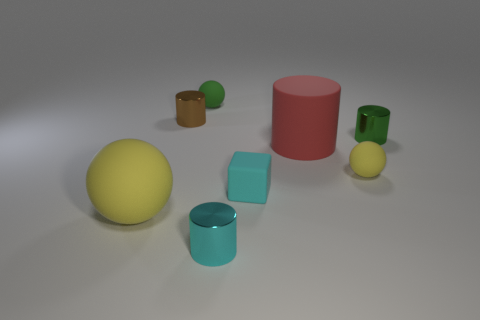The object that is the same color as the block is what shape?
Your response must be concise. Cylinder. What material is the tiny ball behind the tiny metal thing on the right side of the tiny matte sphere in front of the small green metal cylinder made of?
Make the answer very short. Rubber. There is a green object that is to the left of the tiny block; is it the same size as the cylinder that is behind the green metallic object?
Your answer should be very brief. Yes. What number of other things are the same material as the small brown thing?
Make the answer very short. 2. How many metal objects are tiny blocks or big gray spheres?
Your response must be concise. 0. Is the number of tiny yellow balls less than the number of large gray objects?
Your answer should be compact. No. Does the red matte cylinder have the same size as the yellow matte thing to the left of the red rubber thing?
Make the answer very short. Yes. Is there any other thing that has the same shape as the green matte thing?
Your answer should be very brief. Yes. The red object has what size?
Your response must be concise. Large. Is the number of tiny cylinders that are behind the tiny brown object less than the number of big yellow matte balls?
Offer a terse response. Yes. 